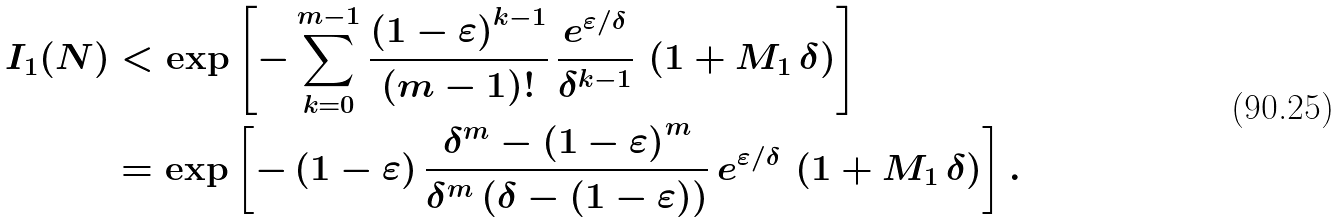Convert formula to latex. <formula><loc_0><loc_0><loc_500><loc_500>I _ { 1 } ( N ) & < \exp \left [ - \sum _ { k = 0 } ^ { m - 1 } \frac { \left ( 1 - \varepsilon \right ) ^ { k - 1 } } { \left ( m - 1 \right ) ! } \, \frac { e ^ { \varepsilon / \delta } } { \delta ^ { k - 1 } } \, \left ( 1 + M _ { 1 } \, \delta \right ) \right ] \\ & = \exp \left [ - \left ( 1 - \varepsilon \right ) \frac { \delta ^ { m } - \left ( 1 - \varepsilon \right ) ^ { m } } { \delta ^ { m } \left ( \delta - \left ( 1 - \varepsilon \right ) \right ) } \, e ^ { \varepsilon / \delta } \, \left ( 1 + M _ { 1 } \, \delta \right ) \right ] .</formula> 